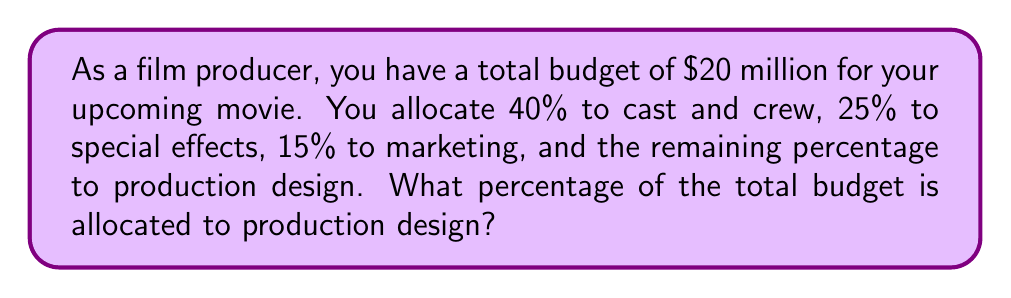Could you help me with this problem? Let's approach this step-by-step:

1. First, let's identify the known percentages:
   - Cast and crew: 40%
   - Special effects: 25%
   - Marketing: 15%

2. To find the percentage allocated to production design, we need to subtract the sum of the known percentages from 100%:

   $$100\% - (40\% + 25\% + 15\%)$$

3. Let's add the known percentages:
   $$40\% + 25\% + 15\% = 80\%$$

4. Now, we can subtract this from 100%:
   $$100\% - 80\% = 20\%$$

Therefore, the percentage allocated to production design is 20% of the total budget.
Answer: 20% 